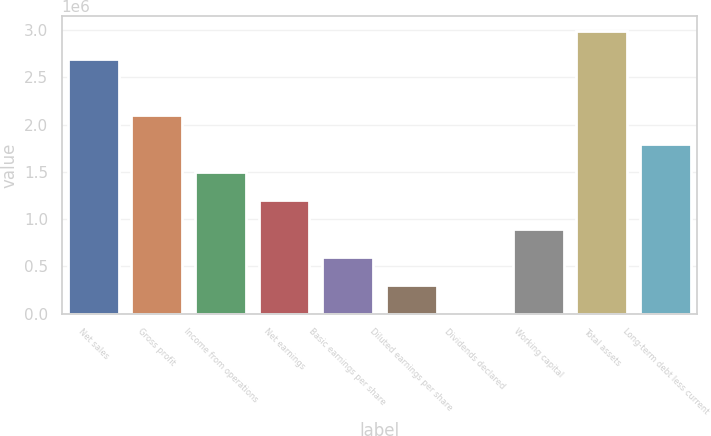<chart> <loc_0><loc_0><loc_500><loc_500><bar_chart><fcel>Net sales<fcel>Gross profit<fcel>Income from operations<fcel>Net earnings<fcel>Basic earnings per share<fcel>Diluted earnings per share<fcel>Dividends declared<fcel>Working capital<fcel>Total assets<fcel>Long-term debt less current<nl><fcel>2.69582e+06<fcel>2.09675e+06<fcel>1.49768e+06<fcel>1.19814e+06<fcel>599072<fcel>299536<fcel>0.24<fcel>898608<fcel>2.99536e+06<fcel>1.79722e+06<nl></chart> 